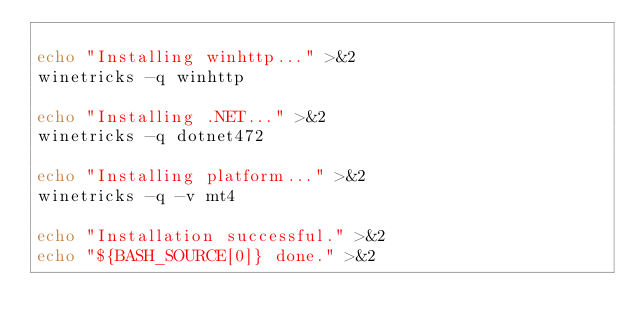<code> <loc_0><loc_0><loc_500><loc_500><_Bash_>
echo "Installing winhttp..." >&2
winetricks -q winhttp

echo "Installing .NET..." >&2
winetricks -q dotnet472

echo "Installing platform..." >&2
winetricks -q -v mt4

echo "Installation successful." >&2
echo "${BASH_SOURCE[0]} done." >&2
</code> 